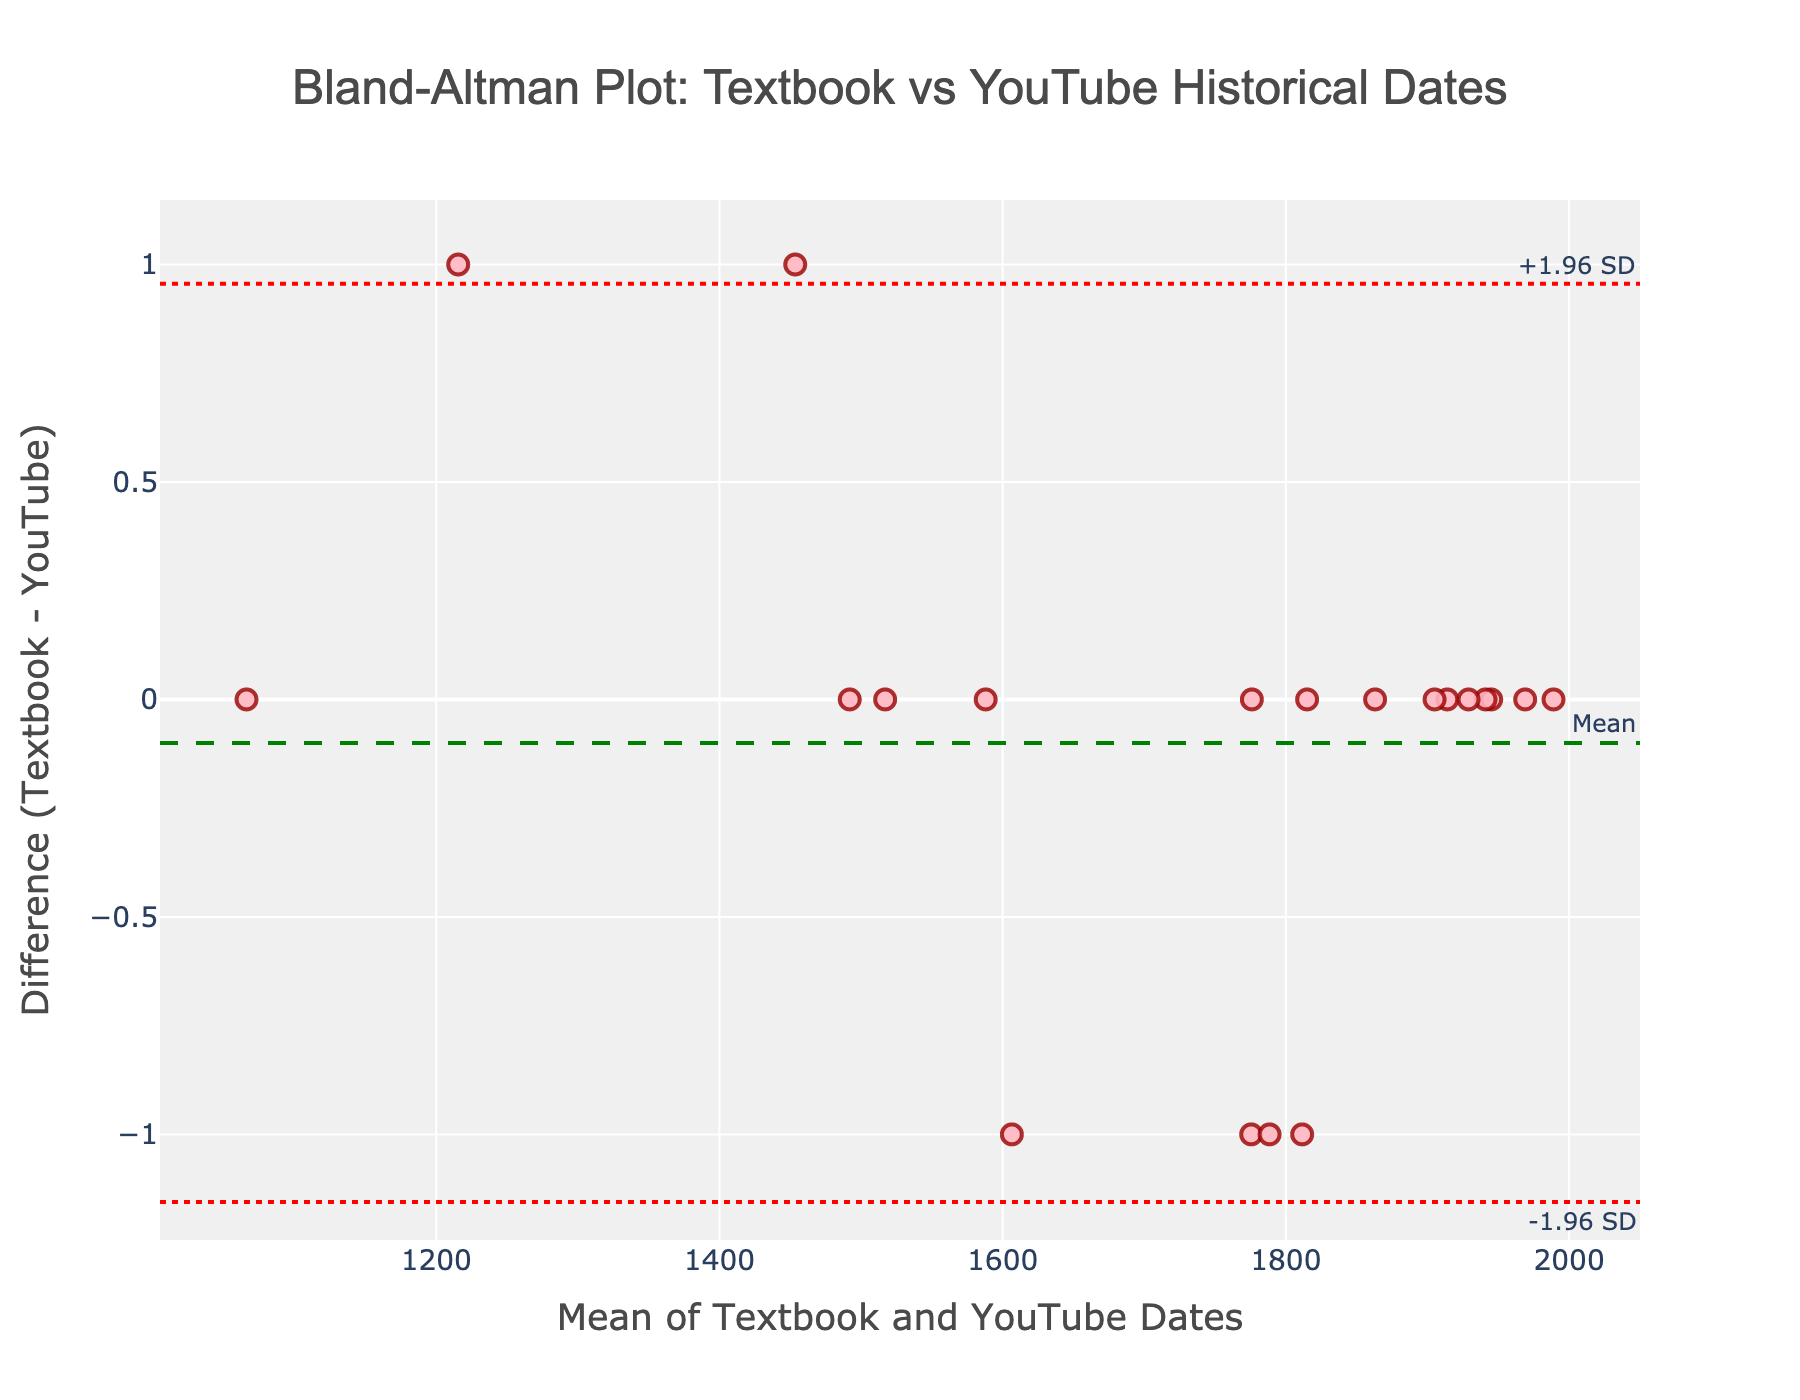What's the title of the plot? The title is displayed at the top of the plot.
Answer: Bland-Altman Plot: Textbook vs YouTube Historical Dates How many data points are represented in the plot? Each marker represents a data point, and you can count the markers in the plot.
Answer: 20 What does the dashed green line represent? The annotation next to the dashed green line states "Mean," indicating that this line represents the mean difference between the textbook and YouTube dates.
Answer: Mean difference Which lines depict the limits of agreement, and what are their values? The red dotted lines marked "-1.96 SD" and "+1.96 SD" show the limits of agreement. The exact values are displayed next to these lines on the y-axis.
Answer: -1.96 SD and +1.96 SD What is the y-axis labeling in the plot? The y-axis label explains what the y-axis values represent and is located next to the y-axis line.
Answer: Difference (Textbook - YouTube) What is the mean difference between textbook and YouTube dates? The green dashed line, annotated as "Mean," indicates the average difference, which can also be approximated visually from its position on the y-axis.
Answer: 0 Which data points have the maximum difference in years? Locate the markers furthest from the mean difference line on the plot, which will either be along the "-1.96 SD" or "+1.96 SD" lines.
Answer: Data points with differences of ±1 Are there more data points above or below the mean difference line? Count the number of markers above and below the green dashed line to compare.
Answer: Equal (10 above, 10 below) What is the x-axis labeling in the plot? The x-axis label explains what the x-axis values represent and is located next to the x-axis line.
Answer: Mean of Textbook and YouTube Dates Is there any systematic bias in YouTube historical dates relative to textbooks? If the data points are uniformly distributed around the mean difference line and within the limits, there's no systematic bias. If they cluster on one side, there's bias.
Answer: No systematic bias 